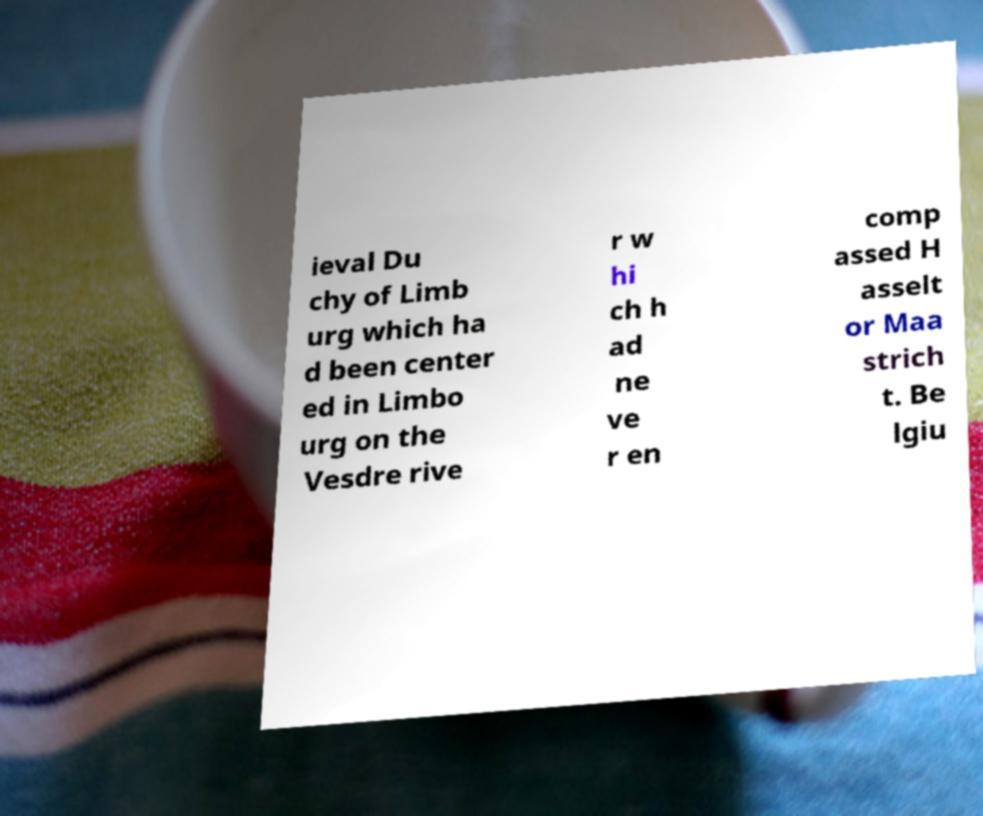Can you read and provide the text displayed in the image?This photo seems to have some interesting text. Can you extract and type it out for me? ieval Du chy of Limb urg which ha d been center ed in Limbo urg on the Vesdre rive r w hi ch h ad ne ve r en comp assed H asselt or Maa strich t. Be lgiu 